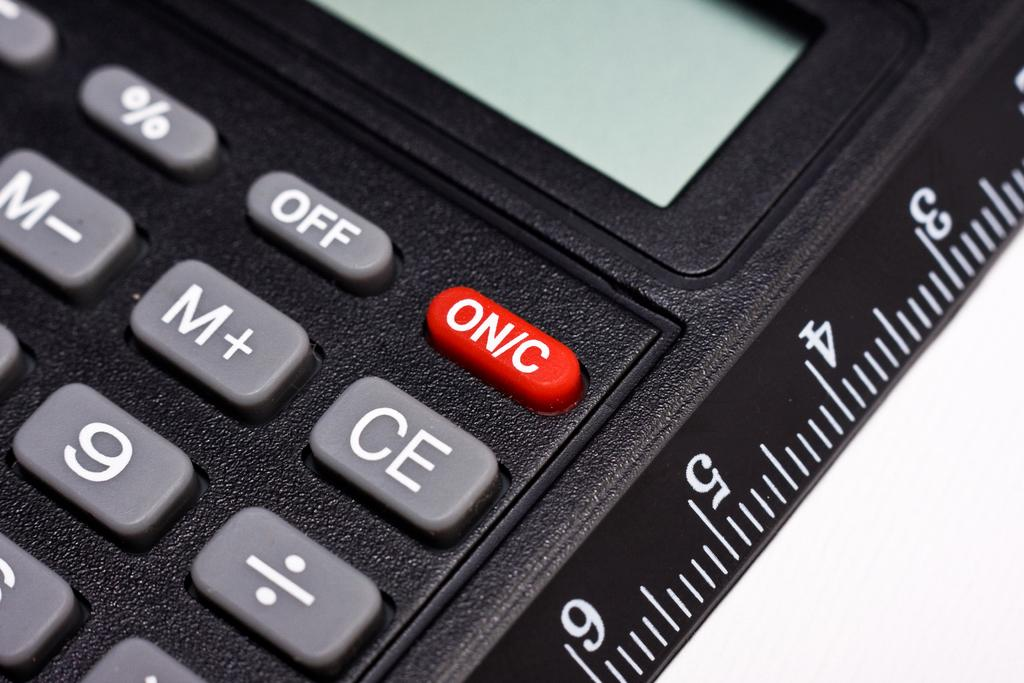<image>
Offer a succinct explanation of the picture presented. A calculator with one edge marked as a ruler and a red ON/C button. 